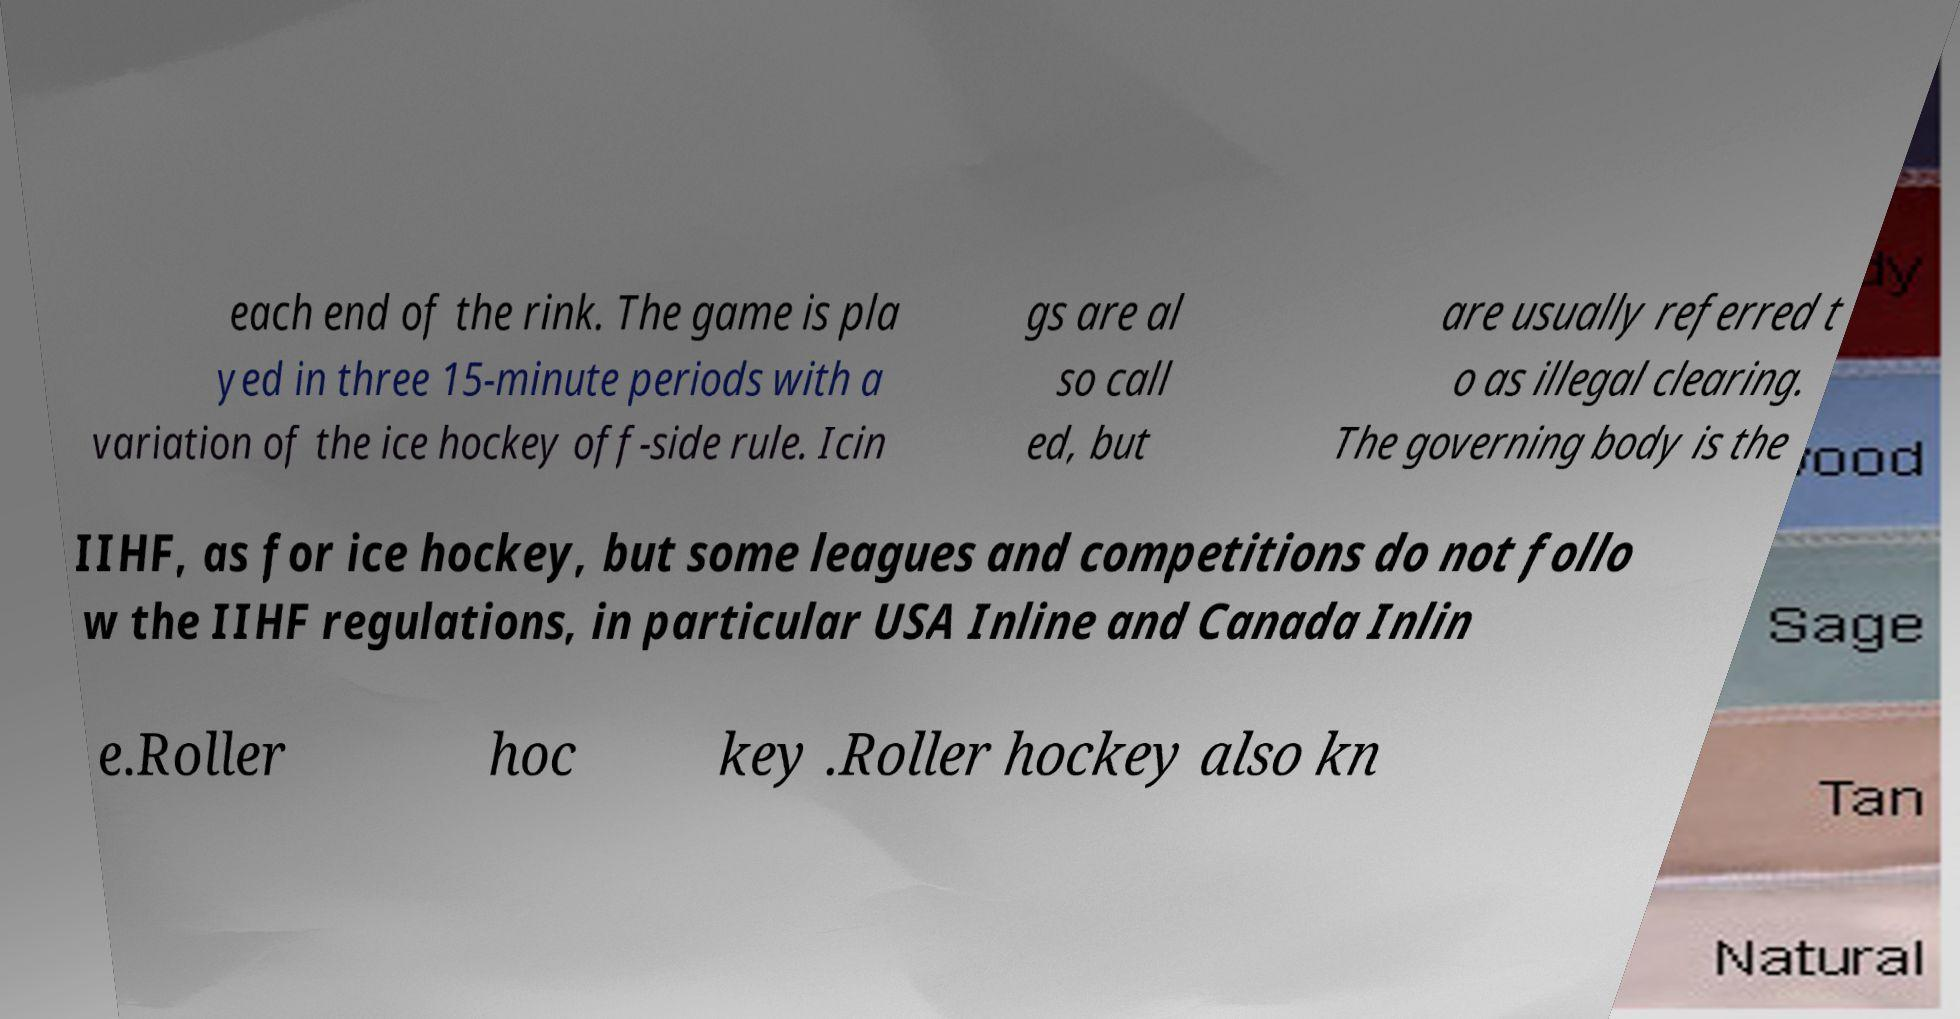There's text embedded in this image that I need extracted. Can you transcribe it verbatim? each end of the rink. The game is pla yed in three 15-minute periods with a variation of the ice hockey off-side rule. Icin gs are al so call ed, but are usually referred t o as illegal clearing. The governing body is the IIHF, as for ice hockey, but some leagues and competitions do not follo w the IIHF regulations, in particular USA Inline and Canada Inlin e.Roller hoc key .Roller hockey also kn 